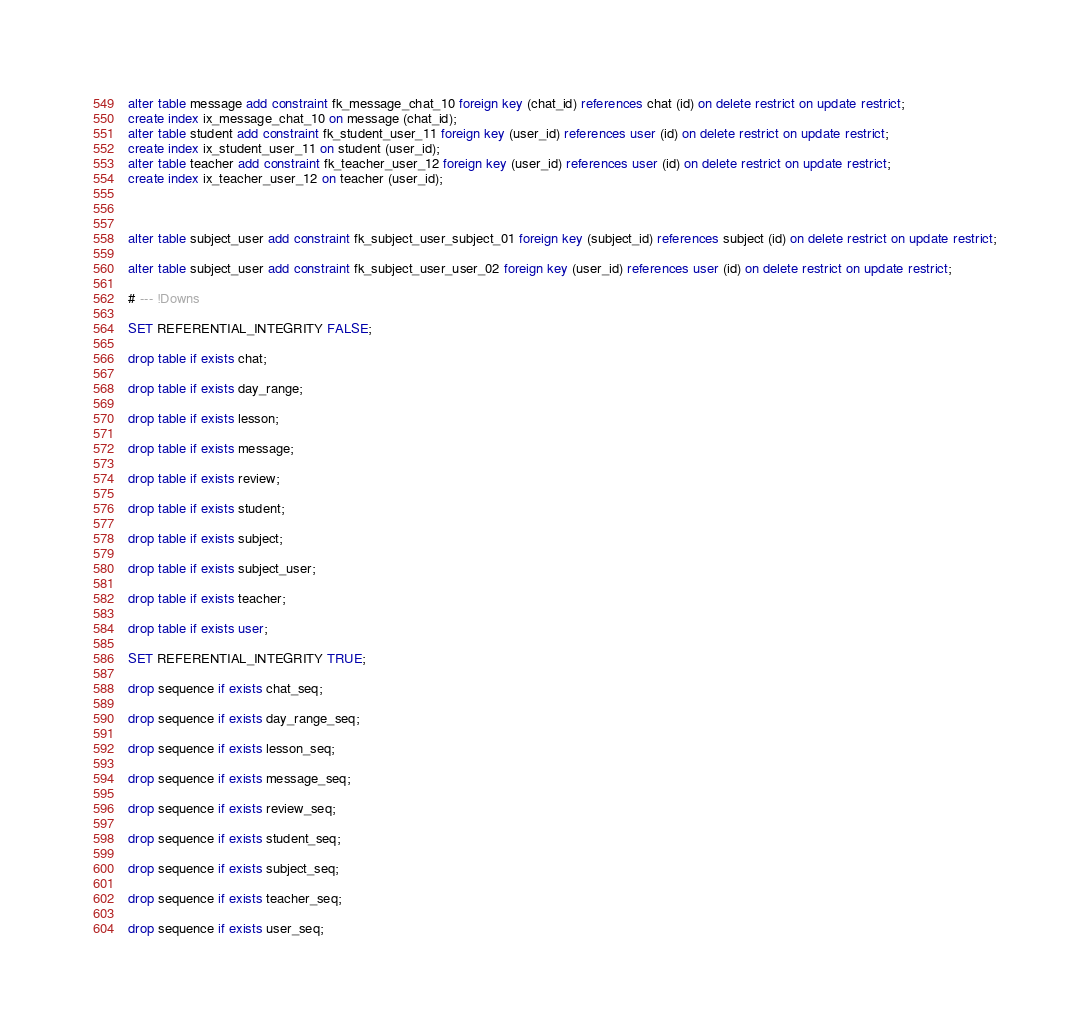Convert code to text. <code><loc_0><loc_0><loc_500><loc_500><_SQL_>alter table message add constraint fk_message_chat_10 foreign key (chat_id) references chat (id) on delete restrict on update restrict;
create index ix_message_chat_10 on message (chat_id);
alter table student add constraint fk_student_user_11 foreign key (user_id) references user (id) on delete restrict on update restrict;
create index ix_student_user_11 on student (user_id);
alter table teacher add constraint fk_teacher_user_12 foreign key (user_id) references user (id) on delete restrict on update restrict;
create index ix_teacher_user_12 on teacher (user_id);



alter table subject_user add constraint fk_subject_user_subject_01 foreign key (subject_id) references subject (id) on delete restrict on update restrict;

alter table subject_user add constraint fk_subject_user_user_02 foreign key (user_id) references user (id) on delete restrict on update restrict;

# --- !Downs

SET REFERENTIAL_INTEGRITY FALSE;

drop table if exists chat;

drop table if exists day_range;

drop table if exists lesson;

drop table if exists message;

drop table if exists review;

drop table if exists student;

drop table if exists subject;

drop table if exists subject_user;

drop table if exists teacher;

drop table if exists user;

SET REFERENTIAL_INTEGRITY TRUE;

drop sequence if exists chat_seq;

drop sequence if exists day_range_seq;

drop sequence if exists lesson_seq;

drop sequence if exists message_seq;

drop sequence if exists review_seq;

drop sequence if exists student_seq;

drop sequence if exists subject_seq;

drop sequence if exists teacher_seq;

drop sequence if exists user_seq;

</code> 